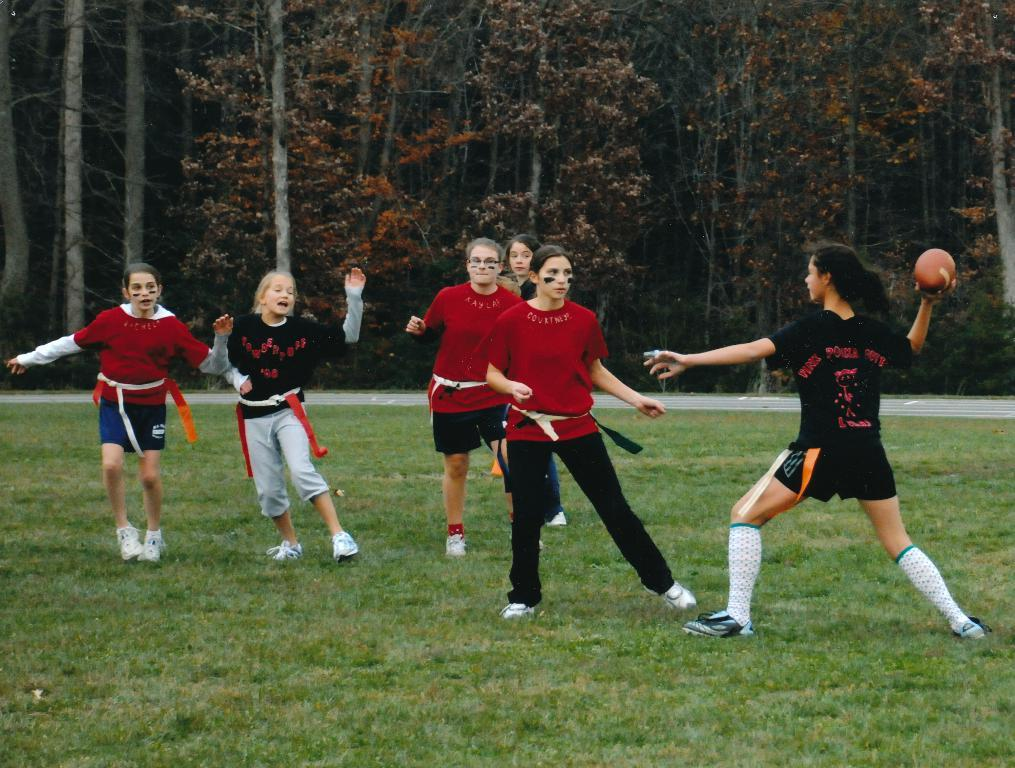Who is the main subject in the image? There is a woman in the image. What is the woman holding in the image? The woman is holding a ball. Where is the woman standing in the image? The woman is standing in the grass. What type of vegetation can be seen in the image? There are trees in the image. What type of necklace is the woman wearing in the image? There is no necklace visible in the image; the woman is holding a ball. 